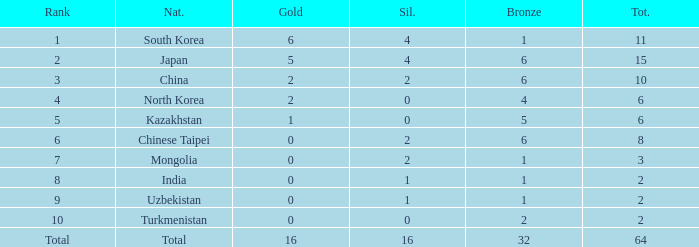What rank is Turkmenistan, who had 0 silver's and Less than 2 golds? 10.0. 